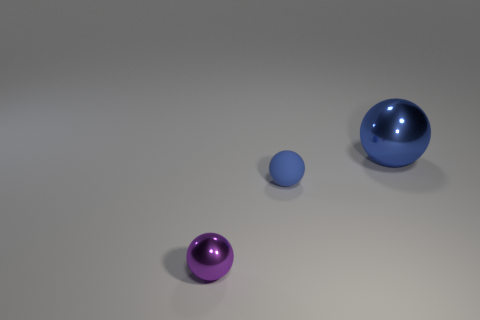Is the number of things left of the purple object greater than the number of small rubber things in front of the blue matte ball?
Your response must be concise. No. What is the size of the other object that is the same material as the big object?
Offer a very short reply. Small. What size is the metal object that is in front of the tiny matte object to the right of the metal object to the left of the blue rubber sphere?
Keep it short and to the point. Small. What is the color of the small thing in front of the matte object?
Offer a very short reply. Purple. Are there more tiny metallic balls behind the small rubber object than small spheres?
Provide a succinct answer. No. There is a metal thing that is right of the small purple ball; is its shape the same as the purple shiny thing?
Offer a very short reply. Yes. What number of green objects are either small metal objects or matte balls?
Provide a succinct answer. 0. Is the number of gray matte cylinders greater than the number of purple balls?
Your answer should be compact. No. There is a shiny thing that is the same size as the blue matte thing; what color is it?
Provide a short and direct response. Purple. What number of blocks are tiny blue things or large shiny objects?
Your answer should be very brief. 0. 